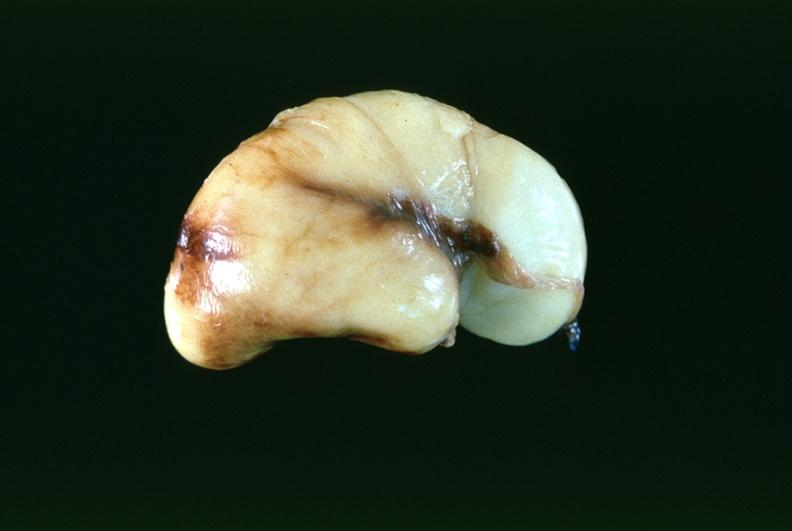does cord show brain, intraventricular hemmorrhage in a prematue baby with hyaline membrane disease?
Answer the question using a single word or phrase. No 